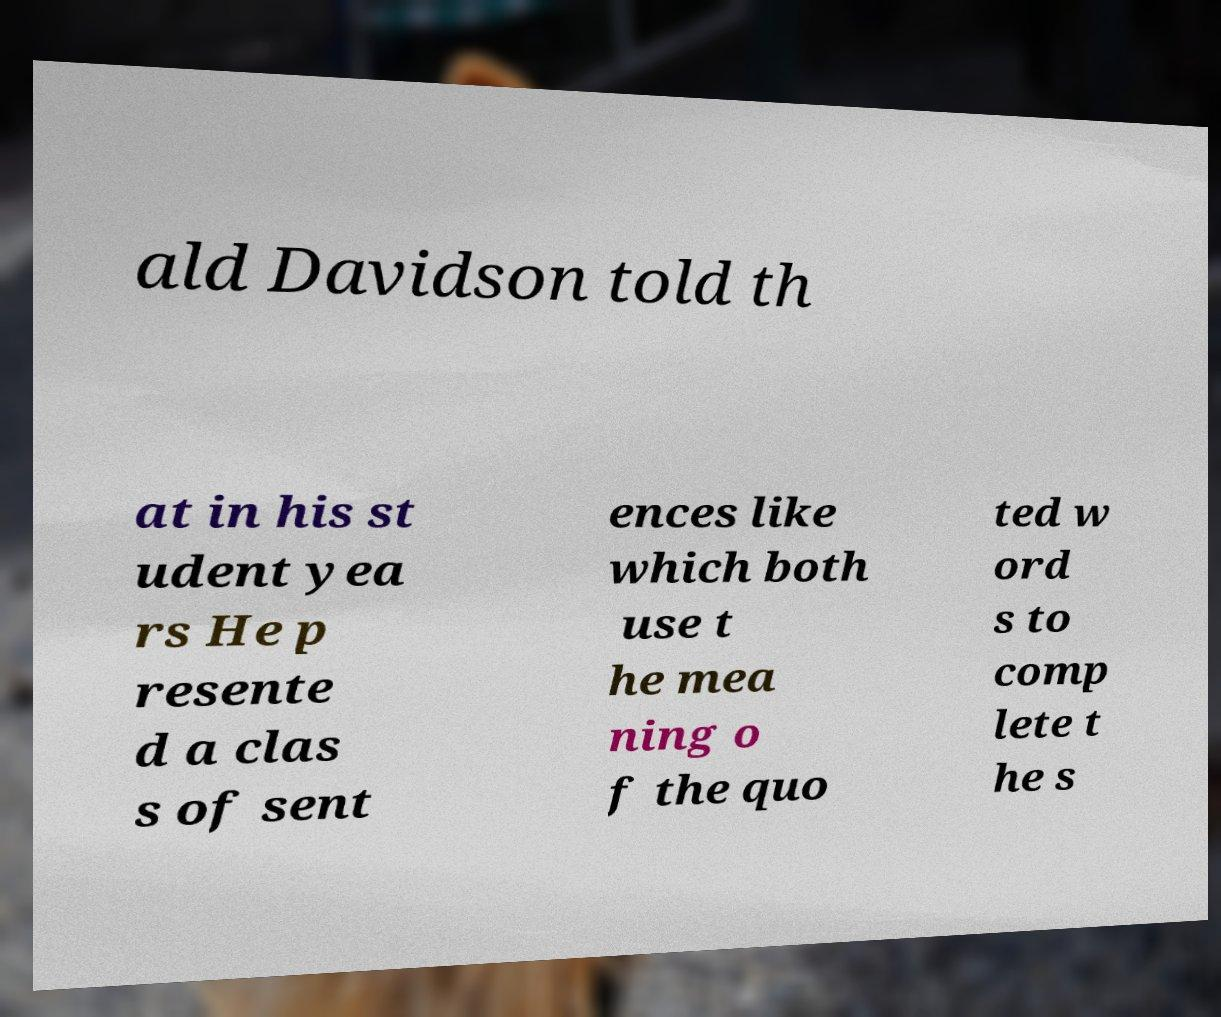I need the written content from this picture converted into text. Can you do that? ald Davidson told th at in his st udent yea rs He p resente d a clas s of sent ences like which both use t he mea ning o f the quo ted w ord s to comp lete t he s 